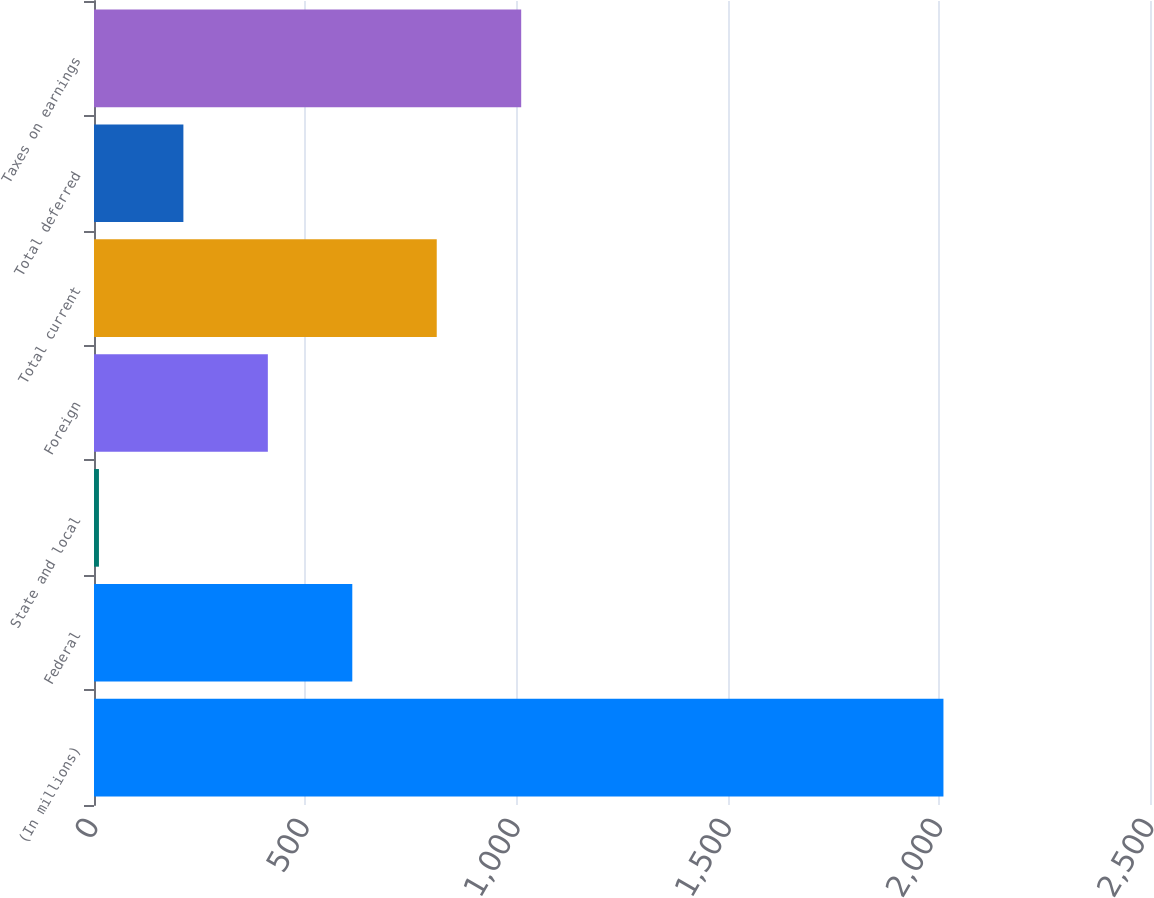Convert chart. <chart><loc_0><loc_0><loc_500><loc_500><bar_chart><fcel>(In millions)<fcel>Federal<fcel>State and local<fcel>Foreign<fcel>Total current<fcel>Total deferred<fcel>Taxes on earnings<nl><fcel>2011<fcel>611.49<fcel>11.7<fcel>411.56<fcel>811.42<fcel>211.63<fcel>1011.35<nl></chart> 